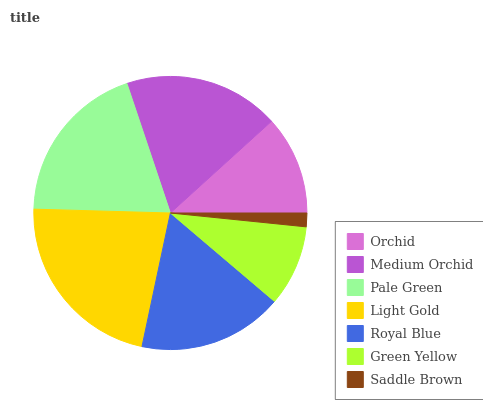Is Saddle Brown the minimum?
Answer yes or no. Yes. Is Light Gold the maximum?
Answer yes or no. Yes. Is Medium Orchid the minimum?
Answer yes or no. No. Is Medium Orchid the maximum?
Answer yes or no. No. Is Medium Orchid greater than Orchid?
Answer yes or no. Yes. Is Orchid less than Medium Orchid?
Answer yes or no. Yes. Is Orchid greater than Medium Orchid?
Answer yes or no. No. Is Medium Orchid less than Orchid?
Answer yes or no. No. Is Royal Blue the high median?
Answer yes or no. Yes. Is Royal Blue the low median?
Answer yes or no. Yes. Is Light Gold the high median?
Answer yes or no. No. Is Orchid the low median?
Answer yes or no. No. 